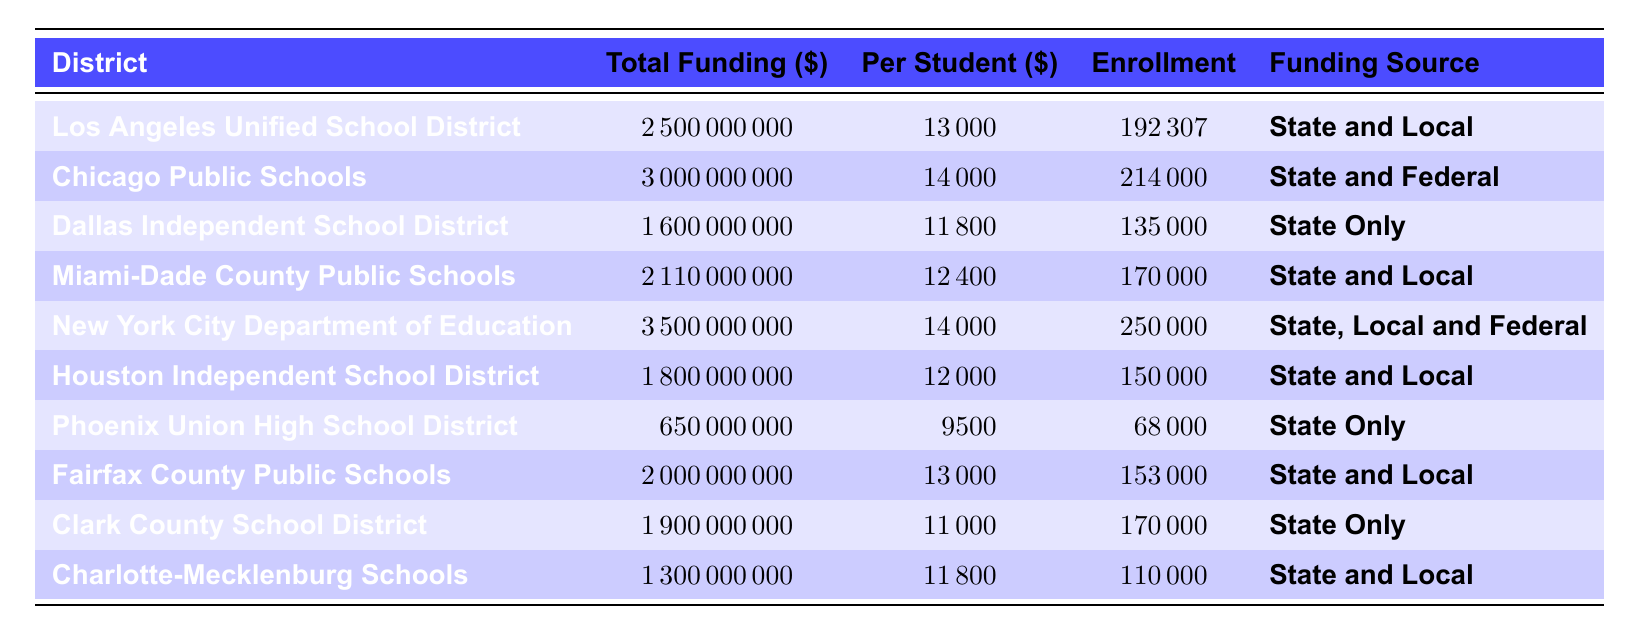What is the total funding for Chicago Public Schools? The table lists the total funding for Chicago Public Schools, which is given as $3,000,000,000.
Answer: 3,000,000,000 What is the per-student funding for the Phoenix Union High School District? According to the table, the per-student funding for the Phoenix Union High School District is $9,500.
Answer: 9,500 Which district has the highest total funding? The table shows that New York City Department of Education has the highest total funding, at $3,500,000,000.
Answer: New York City Department of Education Calculate the average per-student funding across all districts. First, sum the per-student funding values: (13000 + 14000 + 11800 + 12400 + 14000 + 12000 + 9500 + 13000 + 11000 + 11800) = 1,290,000. There are 10 districts, so the average is 1,290,000 / 10 = 12,900.
Answer: 12,900 Is the total funding for Dallas Independent School District less than the total funding for Miami-Dade County Public Schools? The total funding for Dallas Independent School District is $1,600,000,000 and for Miami-Dade County Public Schools is $2,110,000,000. Since $1,600,000,000 is less than $2,110,000,000, the statement is true.
Answer: Yes Which funding source is associated with the highest student enrollment? The highest student enrollment is for New York City Department of Education, with 250,000 students. This district also has a funding source of state, local, and federal.
Answer: State, Local, and Federal What is the difference in total funding between Los Angeles Unified School District and Clark County School District? Total funding for Los Angeles Unified is $2,500,000,000 and for Clark County is $1,900,000,000. The difference is $2,500,000,000 - $1,900,000,000 = $600,000,000.
Answer: 600,000,000 Are there any districts that rely solely on state funding? The districts that rely solely on state funding are Dallas Independent School District and Phoenix Union High School District, as mentioned in the table. Therefore, the answer is yes.
Answer: Yes Which district has the lowest per-student funding? The lowest per-student funding in the table is for Phoenix Union High School District, which is $9,500.
Answer: Phoenix Union High School District Calculate the total projected enrollment for districts that have state and local funding. The projected enrollments for districts with state and local funding are: Los Angeles Unified (192,307), Miami-Dade County (170,000), Houston Independent (150,000), Fairfax County (153,000), and Charlotte-Mecklenburg (110,000). Summing these gives: 192,307 + 170,000 + 150,000 + 153,000 + 110,000 = 775,307.
Answer: 775,307 